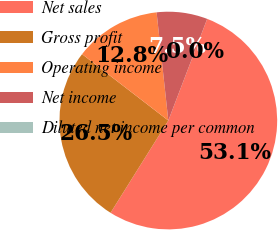<chart> <loc_0><loc_0><loc_500><loc_500><pie_chart><fcel>Net sales<fcel>Gross profit<fcel>Operating income<fcel>Net income<fcel>Diluted net income per common<nl><fcel>53.09%<fcel>26.54%<fcel>12.84%<fcel>7.53%<fcel>0.0%<nl></chart> 